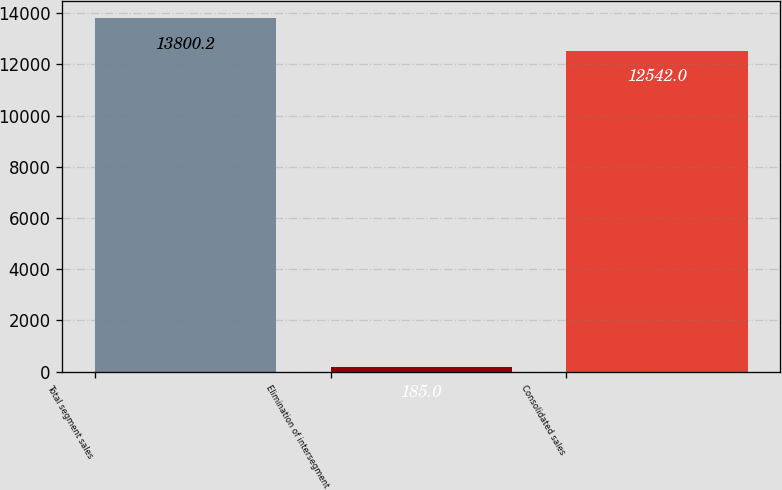Convert chart. <chart><loc_0><loc_0><loc_500><loc_500><bar_chart><fcel>Total segment sales<fcel>Elimination of intersegment<fcel>Consolidated sales<nl><fcel>13800.2<fcel>185<fcel>12542<nl></chart> 